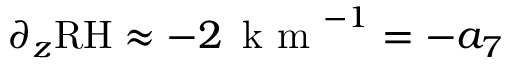Convert formula to latex. <formula><loc_0><loc_0><loc_500><loc_500>\partial _ { z } R H \approx - 2 \, k m ^ { - 1 } = - a _ { 7 }</formula> 